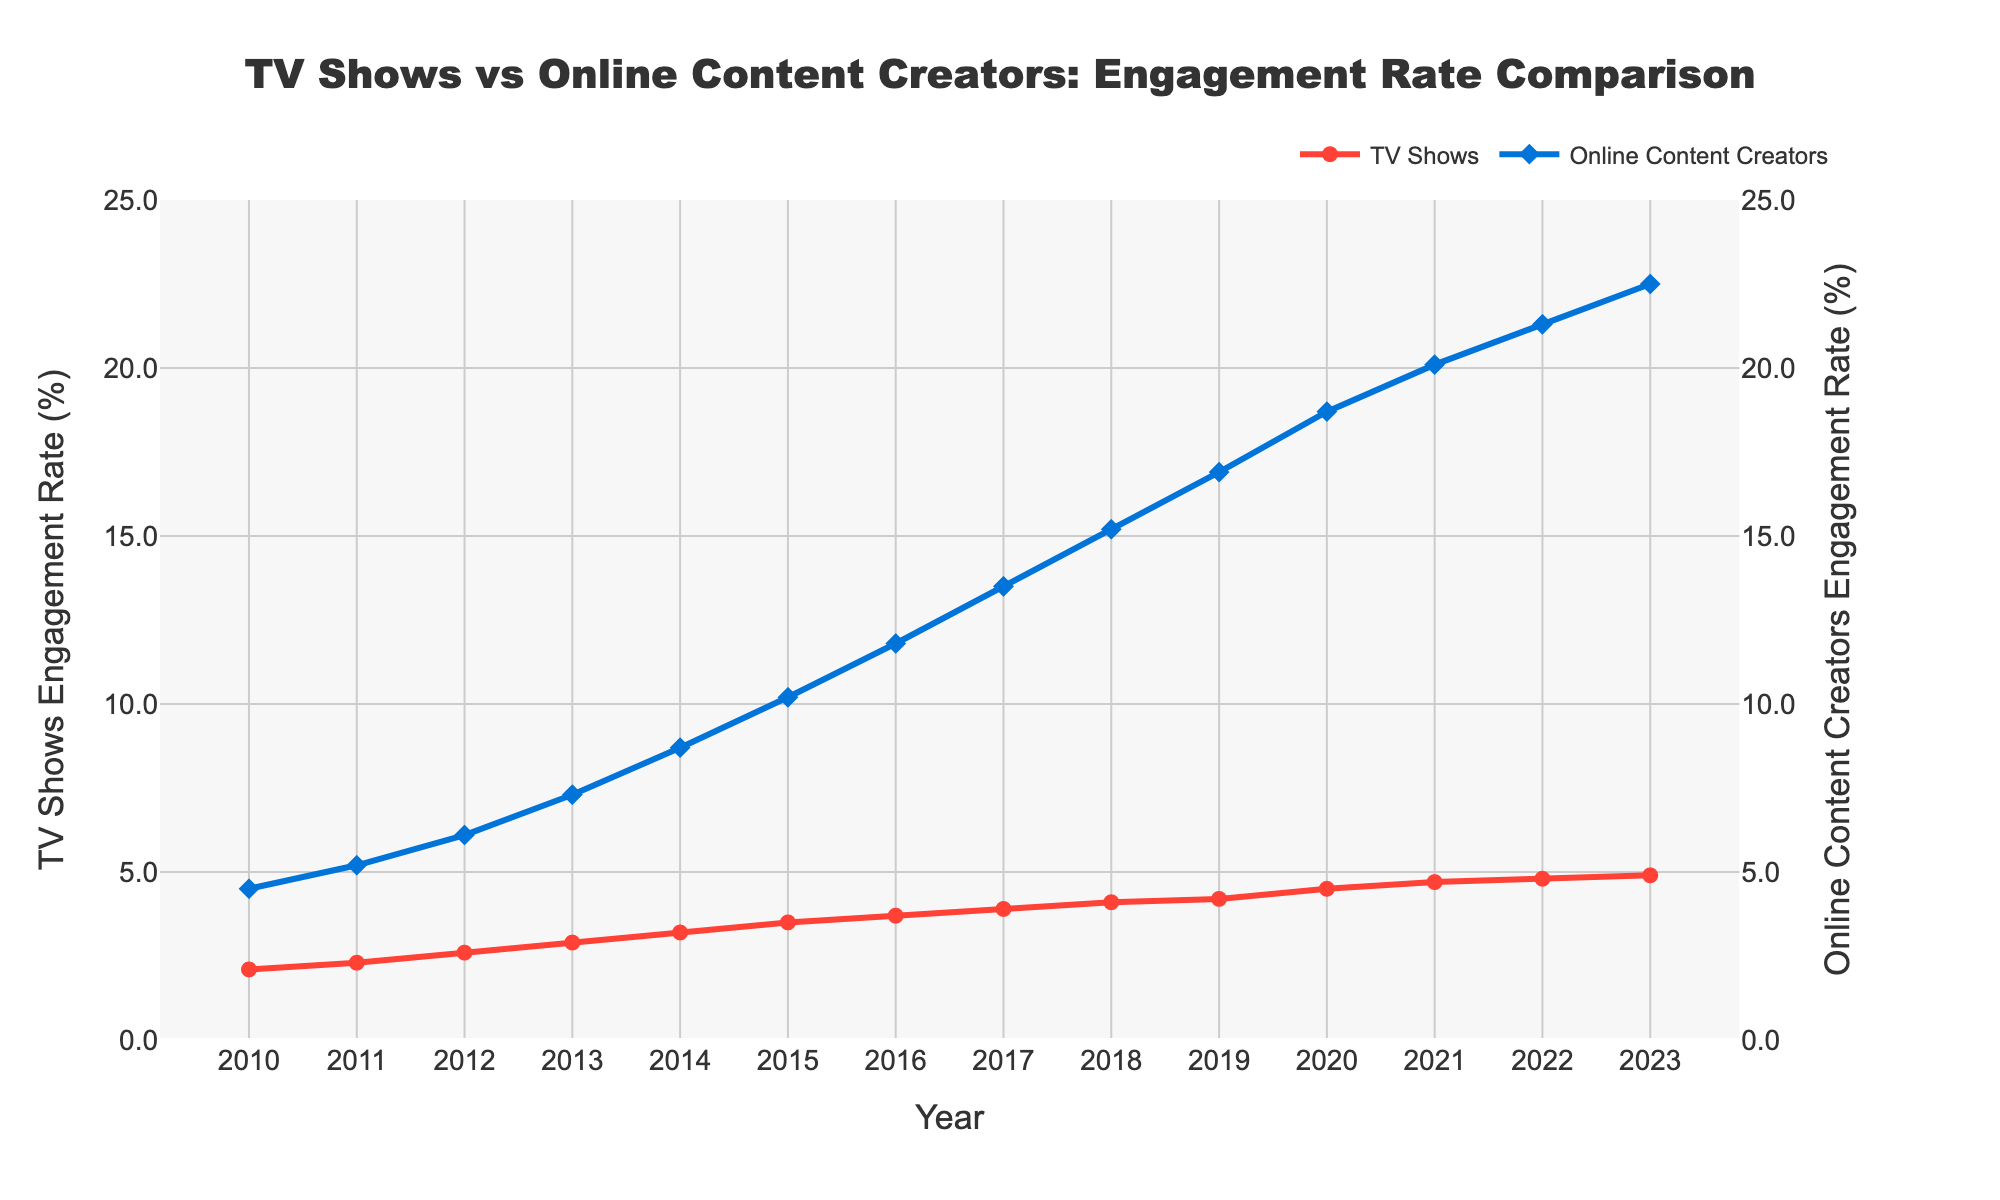Which engagement rate was higher in 2015, TV shows or online content creators? From the plot, in 2015, the engagement rate for TV shows was 3.5%, while for online content creators it was 10.2%. Hence, online content creators had a higher engagement rate.
Answer: Online content creators By how many percentage points did the online content creators' engagement rate increase from 2010 to 2023? The engagement rate for online content creators in 2010 was 4.5%, and in 2023 it was 22.5%. The increase is 22.5% - 4.5% = 18 percentage points.
Answer: 18 percentage points What is the difference between TV shows and online content creators’ engagement rates in 2020? The engagement rate for TV shows in 2020 was 4.5%, and for online content creators, it was 18.7%. The difference is 18.7% - 4.5% = 14.2 percentage points.
Answer: 14.2 percentage points Did TV shows or online content creators experience a faster rate of growth in engagement from 2010 to 2023, in percentage points? TV shows' engagement rate increased from 2.1% in 2010 to 4.9% in 2023, a 2.8 percentage points increase. Online content creators' engagement rate increased from 4.5% in 2010 to 22.5% in 2023, an 18 percentage points increase. Therefore, online content creators experienced a faster rate of growth in percentage points.
Answer: Online content creators What year did online content creators' engagement rate first surpass 10%? Looking at the plot, online content creators' engagement rate first surpassed 10% in 2015 when it reached 10.2%.
Answer: 2015 On average, how much did TV shows’ engagement rate increase per year from 2010 to 2023? The engagement rate for TV shows in 2010 was 2.1%, and in 2023 it was 4.9%. The increase over 13 years is 4.9% - 2.1% = 2.8 percentage points. The average annual increase is 2.8 / 13 ≈ 0.215 percentage points per year.
Answer: Approximately 0.215 percentage points per year Which year shows the greatest one-year increase in engagement rate for online content creators? By examining the plot, the greatest one-year increase in engagement rate for online content creators occurred between 2014 and 2015, jumping from 8.7% to 10.2%, an increase of 1.5 percentage points.
Answer: 2014-2015 Is there any year where the engagement rate for TV shows decreased? From the plot, the engagement rate for TV shows consistently increased each year from 2010 to 2023, never showing a decrease.
Answer: No Comparing the starting values in 2010, how many times greater was the engagement rate for online content creators than TV shows? In 2010, the engagement rate for TV shows was 2.1%, and for online content creators, it was 4.5%. The ratio is 4.5 / 2.1 ≈ 2.14. Therefore, the engagement rate for online content creators was approximately 2.14 times greater.
Answer: Approximately 2.14 times 